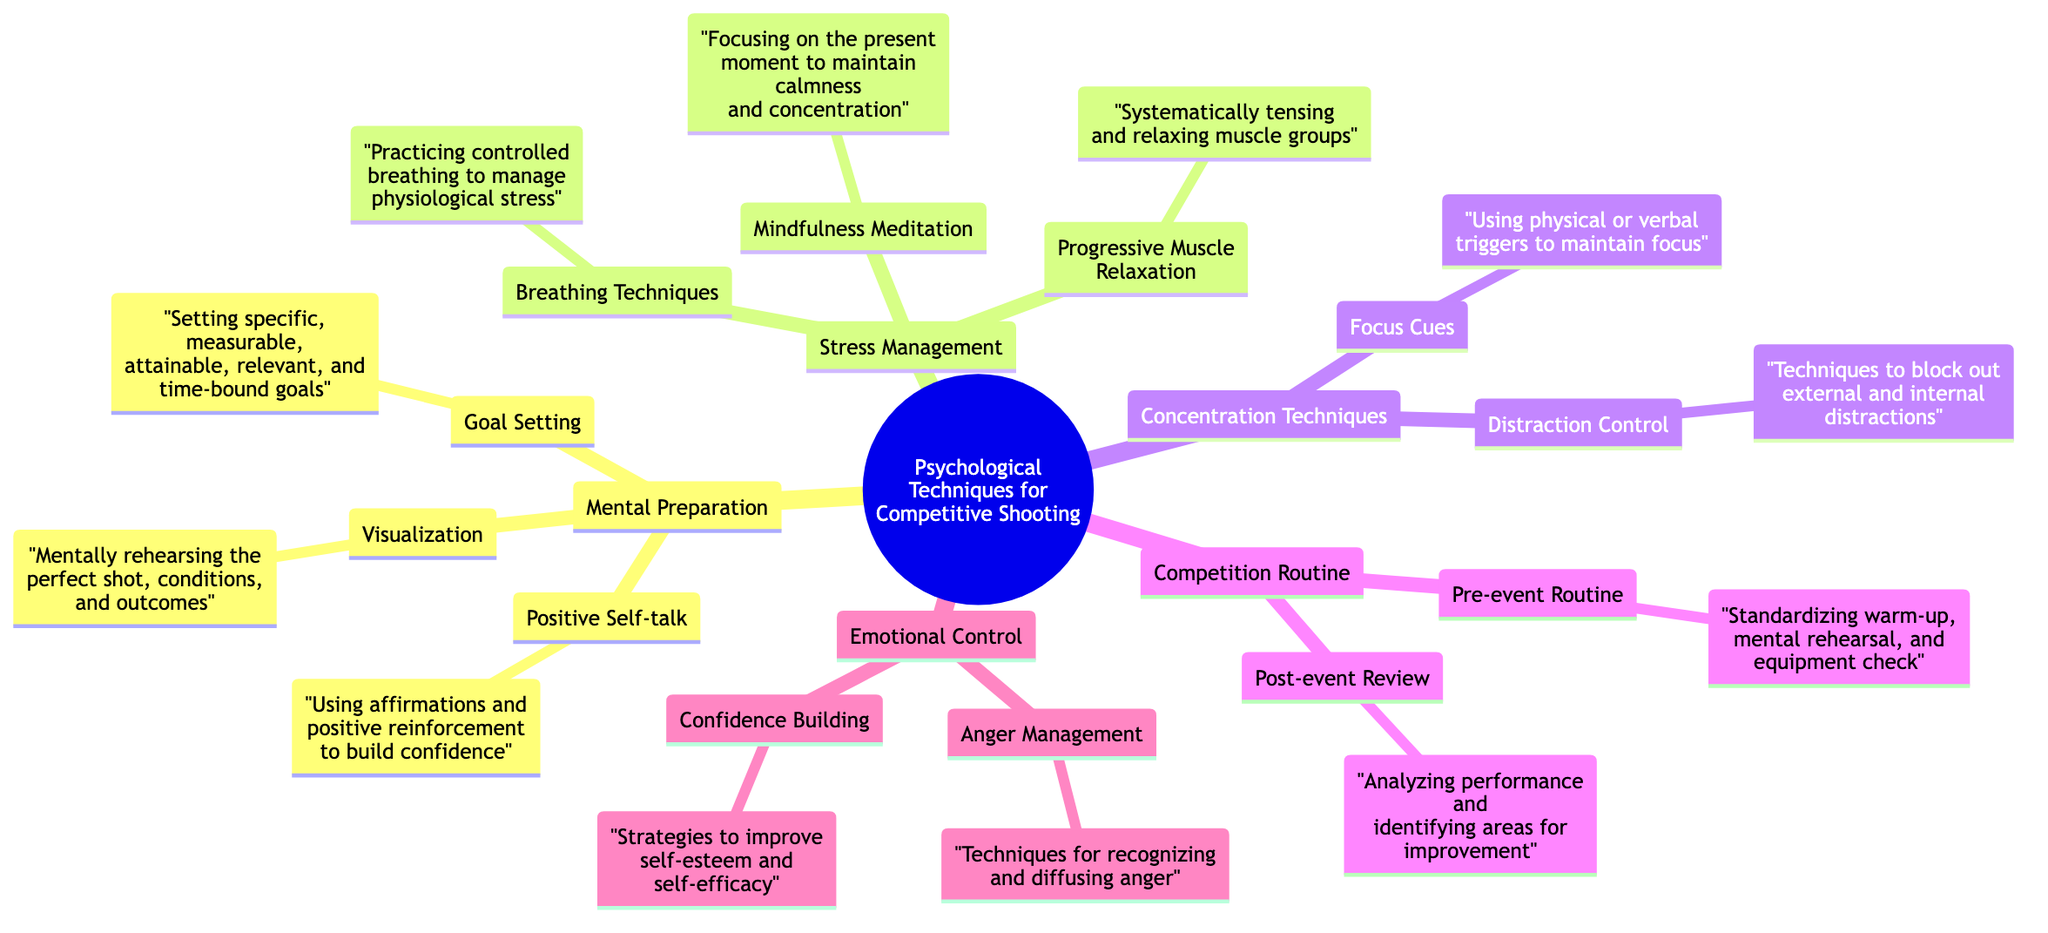What are the three main branches of the mind map? The central topic "Psychological Techniques for Competitive Shooting" has five main branches: Mental Preparation, Stress Management, Concentration Techniques, Competition Routine, and Emotional Control.
Answer: Mental Preparation, Stress Management, Concentration Techniques, Competition Routine, Emotional Control How many sub-branches does the "Stress Management" branch have? The "Stress Management" branch has three sub-branches: Breathing Techniques, Progressive Muscle Relaxation, and Mindfulness Meditation. To count them, we list them: 1) Breathing Techniques, 2) Progressive Muscle Relaxation, 3) Mindfulness Meditation, resulting in three.
Answer: 3 What technique is used to manage physiological stress? The diagram states that "Breathing Techniques" are used for managing physiological stress under the "Stress Management" branch. This can be confirmed by locating the respective node.
Answer: Breathing Techniques Which technique involves recognizing and diffusing anger? The technique for recognizing and diffusing anger is "Anger Management," found under the "Emotional Control" branch. This can be identified by following the flow from the central topic to the sub-branch.
Answer: Anger Management How are the "Pre-event Routine" and "Post-event Review" related? The "Pre-event Routine" and "Post-event Review" are both sub-branches of the "Competition Routine" branch, indicating they are part of the same category of techniques related to competitive shooting processes, specifically focused on preparation and analysis.
Answer: They are both under Competition Routine What is the purpose of "Mindfulness Meditation"? The purpose of "Mindfulness Meditation" is to maintain calmness and concentration, as stated in its description under the "Stress Management" branch. This is derived from reading the details of that specific sub-branch.
Answer: Maintain calmness and concentration What are two examples of "Concentration Techniques"? The two examples of "Concentration Techniques" listed are "Focus Cues" and "Distraction Control." This is determined by identifying the sub-branches under the "Concentration Techniques" main branch.
Answer: Focus Cues, Distraction Control What is meant by "Positive Self-talk"? "Positive Self-talk" refers to using affirmations and positive reinforcement to build confidence, which is detailed under the "Mental Preparation" branch. This can be validated by referring to the description of that specific node.
Answer: Using affirmations and positive reinforcement to build confidence How many total sub-branches are there across all branches? There are 12 sub-branches in total, counted by listing all from each branch: 3 from Mental Preparation, 3 from Stress Management, 2 from Concentration Techniques, 2 from Competition Routine, and 2 from Emotional Control, giving a total of 12.
Answer: 12 